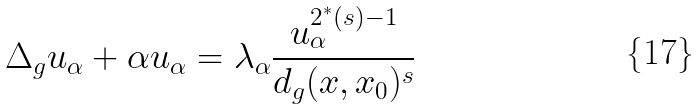Convert formula to latex. <formula><loc_0><loc_0><loc_500><loc_500>\Delta _ { g } u _ { \alpha } + \alpha u _ { \alpha } = \lambda _ { \alpha } \frac { u _ { \alpha } ^ { 2 ^ { * } ( s ) - 1 } } { d _ { g } ( x , x _ { 0 } ) ^ { s } }</formula> 